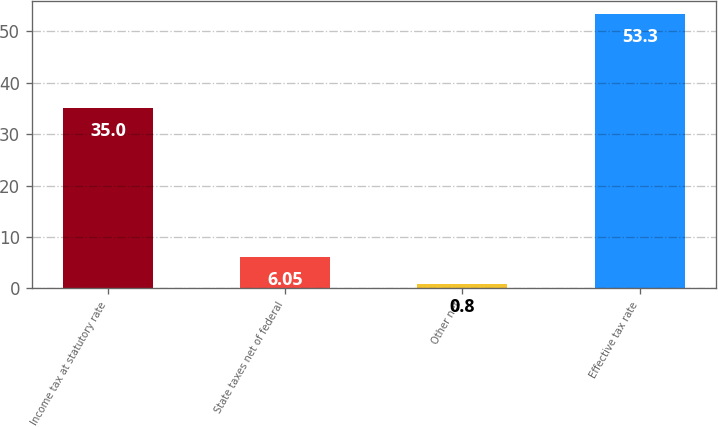Convert chart. <chart><loc_0><loc_0><loc_500><loc_500><bar_chart><fcel>Income tax at statutory rate<fcel>State taxes net of federal<fcel>Other net<fcel>Effective tax rate<nl><fcel>35<fcel>6.05<fcel>0.8<fcel>53.3<nl></chart> 